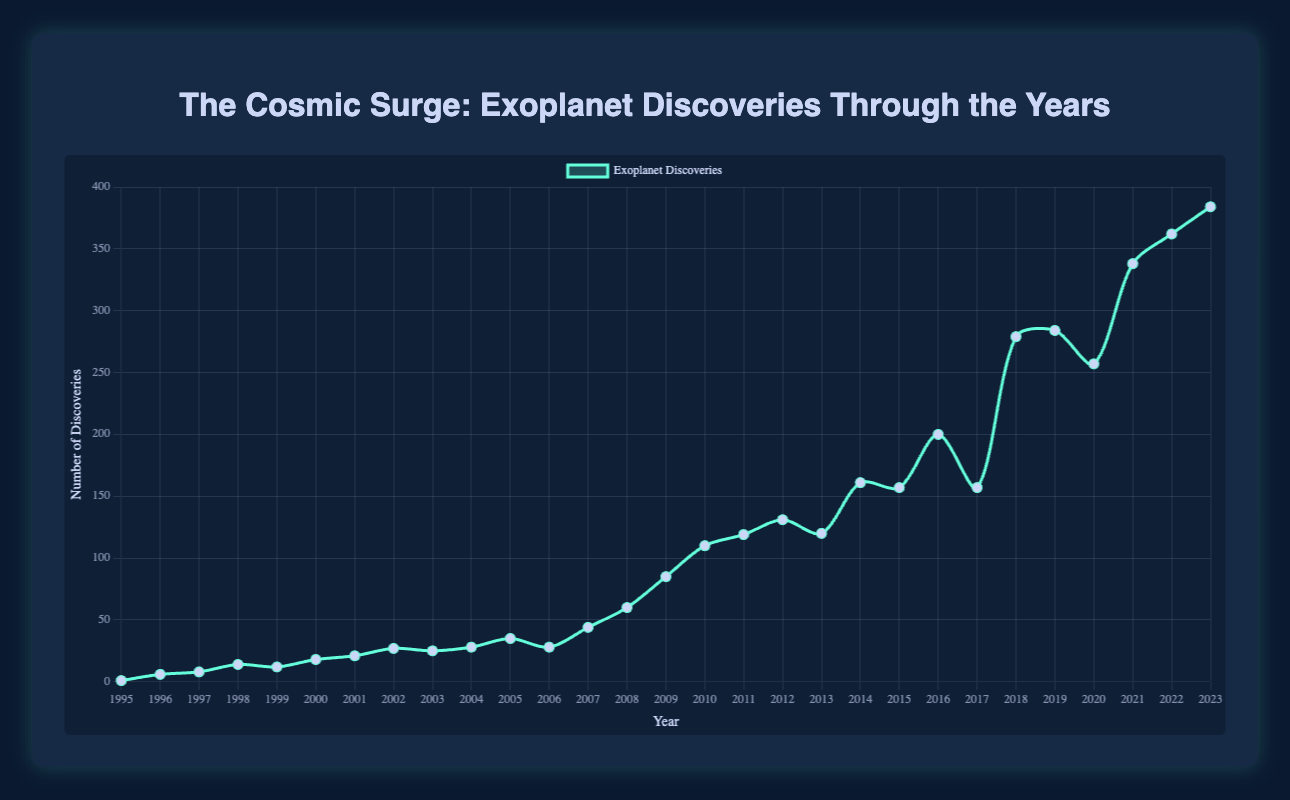What is the year with the highest number of exoplanet discoveries? By looking at the figure, the highest point on the curve represents the year with the most discoveries, which is at 2023.
Answer: 2023 How many exoplanets were discovered in 2010 compared to 2000? In 2020, 110 exoplanets were discovered, and in 2000, 18 were discovered. The difference is 110 - 18 = 92. Thus, 92 more exoplanets were discovered in 2010 compared to 2000.
Answer: 92 What is the trend in exoplanet discoveries from 1995 to 2005? By observing the figure, the curve shows an overall increasing trend in the number of exoplanet discoveries from 1 in 1995 to 35 in 2005. Despite minor fluctuations, this period shows growth in discoveries.
Answer: Increasing In which year did exoplanet discoveries first exceed 100? By checking the y-axis and corresponding years on the figure, the number of discoveries first exceeded 100 in the year 2010 with 110 discoveries.
Answer: 2010 What is the average number of exoplanet discoveries from 2008 to 2012? Calculate the sum of discoveries in these years: 60 (2008) + 85 (2009) + 110 (2010) + 119 (2011) + 131 (2012) = 505. Divide by the number of years, 505/5 = 101.
Answer: 101 Compare the number of exoplanet discoveries between 2015 and 2017. Which year had more discoveries and by how much? In 2015, there were 157 discoveries, and in 2017 there were also 157 discoveries. So neither year had more discoveries compared to the other. The difference is 0.
Answer: 0 Identify the visual trend in the number of exoplanet discoveries from 2008 to 2009. The figure shows a sharp increase in the curve from 2008 (60 discoveries) to 2009 (85 discoveries), indicating a steep upward trend.
Answer: Upward What is the difference between the highest and lowest number of exoplanet discoveries between 1995 and 2023? The highest number of discoveries is 384 in 2023, whereas the lowest is 1 in 1995. The difference is 384 - 1 = 383.
Answer: 383 How did the exoplanet discoveries change from 2019 to 2020? In 2019, there were 284 discoveries, and in 2020 there were 257. The figure shows a slight downward trend in this period, with a decrease of 284 - 257 = 27 discoveries.
Answer: Decrease by 27 